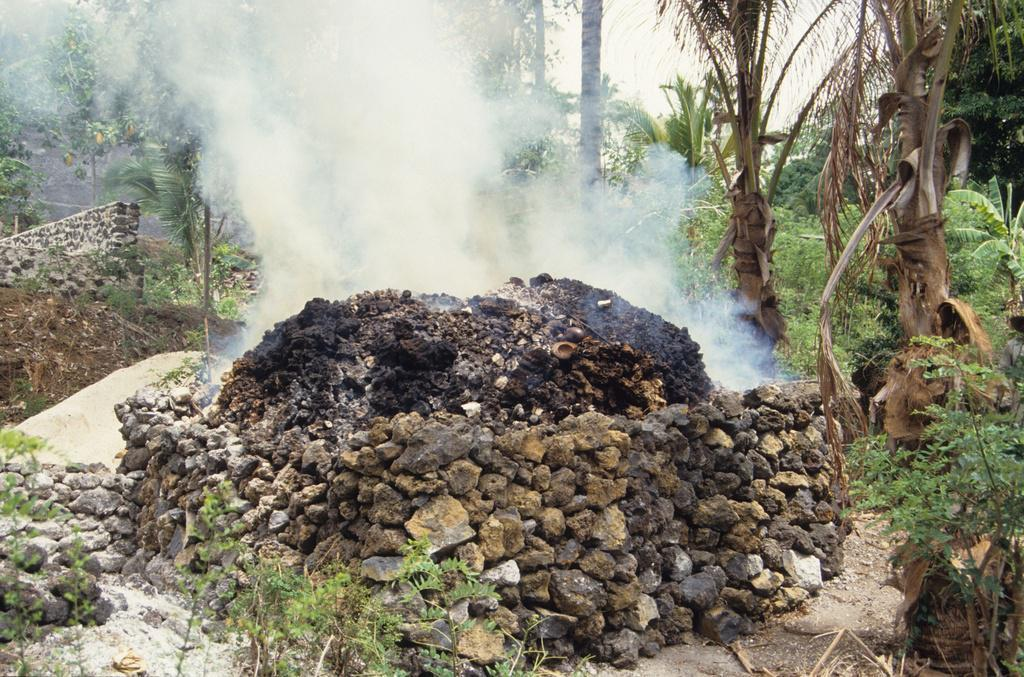What type of barrier can be seen in the foreground of the image? There is a stone fence in the foreground of the image. What type of vegetation is present in the foreground of the image? Grass, plants, and trees are visible in the foreground of the image. What is visible at the top of the image? The sky is visible at the top of the image. When was the image taken? The image was taken during the day. What type of treatment is being administered to the plants in the image? There is no indication in the image that any treatment is being administered to the plants. Can you see any locks on the stone fence in the image? There are no locks visible on the stone fence in the image. 